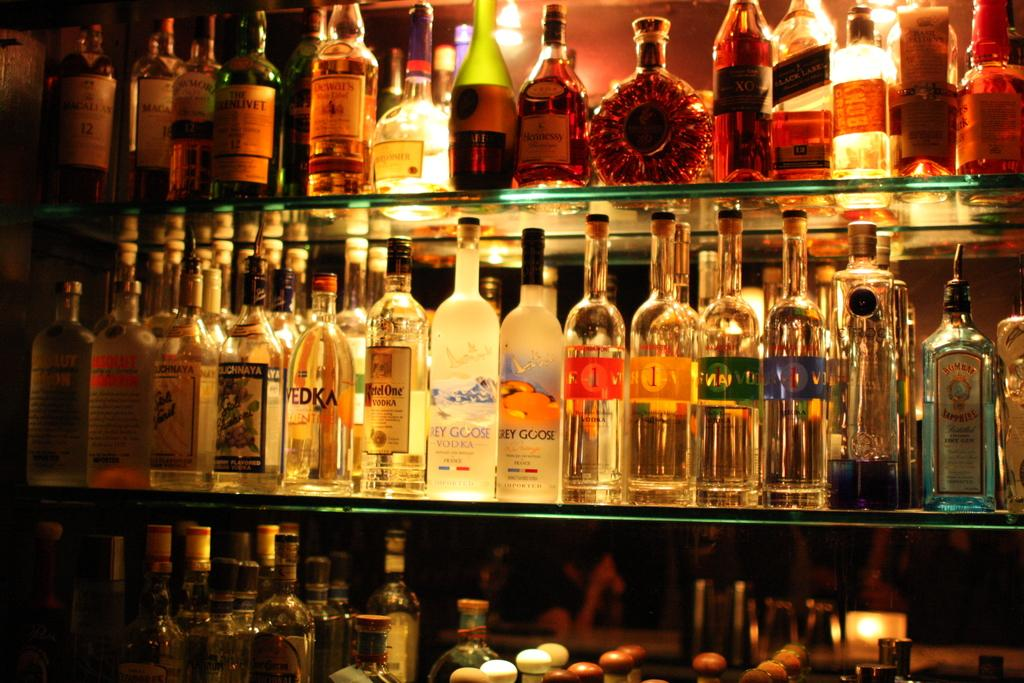What type of bottles are visible in the image? There are wine bottles in the image. Where are the wine bottles located? The wine bottles are on shelves. What type of guitar is leaning against the wall in the image? There is no guitar present in the image; it only features wine bottles on shelves. 